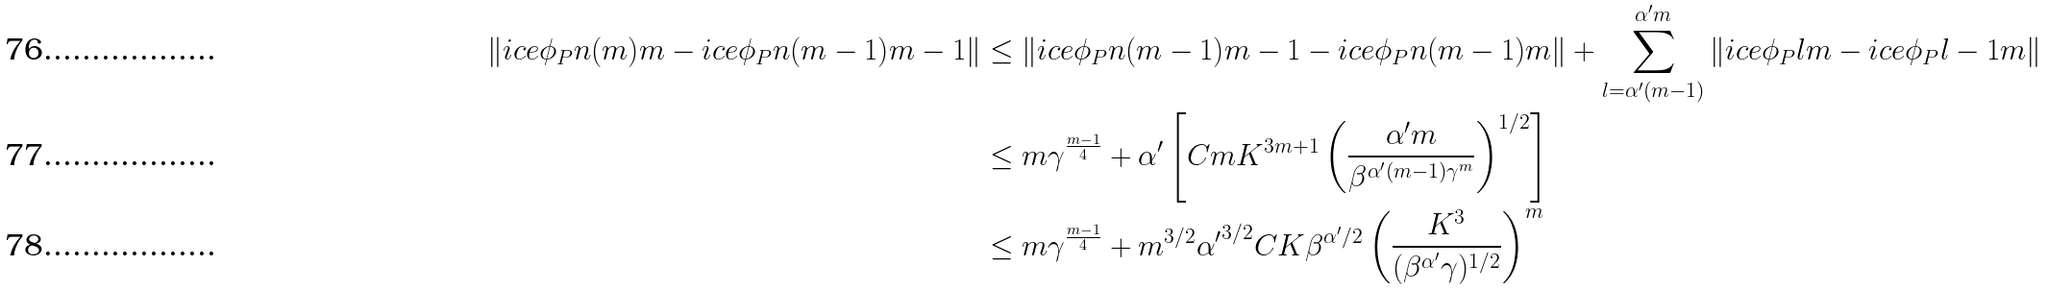Convert formula to latex. <formula><loc_0><loc_0><loc_500><loc_500>\| \sl i c e { \phi _ { P } } { n ( m ) } { m } - \sl i c e { \phi _ { P } } { n ( m - 1 ) } { m - 1 } \| & \leq \| \sl i c e { \phi _ { P } } { n ( m - 1 ) } { m - 1 } - \sl i c e { \phi _ { P } } { n ( m - 1 ) } { m } \| + \sum _ { l = \alpha ^ { \prime } ( m - 1 ) } ^ { \alpha ^ { \prime } m } \| \sl i c e { \phi _ { P } } { l } { m } - \sl i c e { \phi _ { P } } { l - 1 } { m } \| \\ & \leq m \gamma ^ { \frac { m - 1 } { 4 } } + \alpha ^ { \prime } \left [ C m K ^ { 3 m + 1 } \left ( \frac { \alpha ^ { \prime } m } { \beta ^ { \alpha ^ { \prime } ( m - 1 ) \gamma ^ { m } } } \right ) ^ { 1 / 2 } \right ] \\ & \leq m \gamma ^ { \frac { m - 1 } { 4 } } + m ^ { 3 / 2 } { \alpha ^ { \prime } } ^ { 3 / 2 } C K \beta ^ { \alpha ^ { \prime } / 2 } \left ( \frac { K ^ { 3 } } { ( \beta ^ { \alpha ^ { \prime } } \gamma ) ^ { 1 / 2 } } \right ) ^ { m }</formula> 